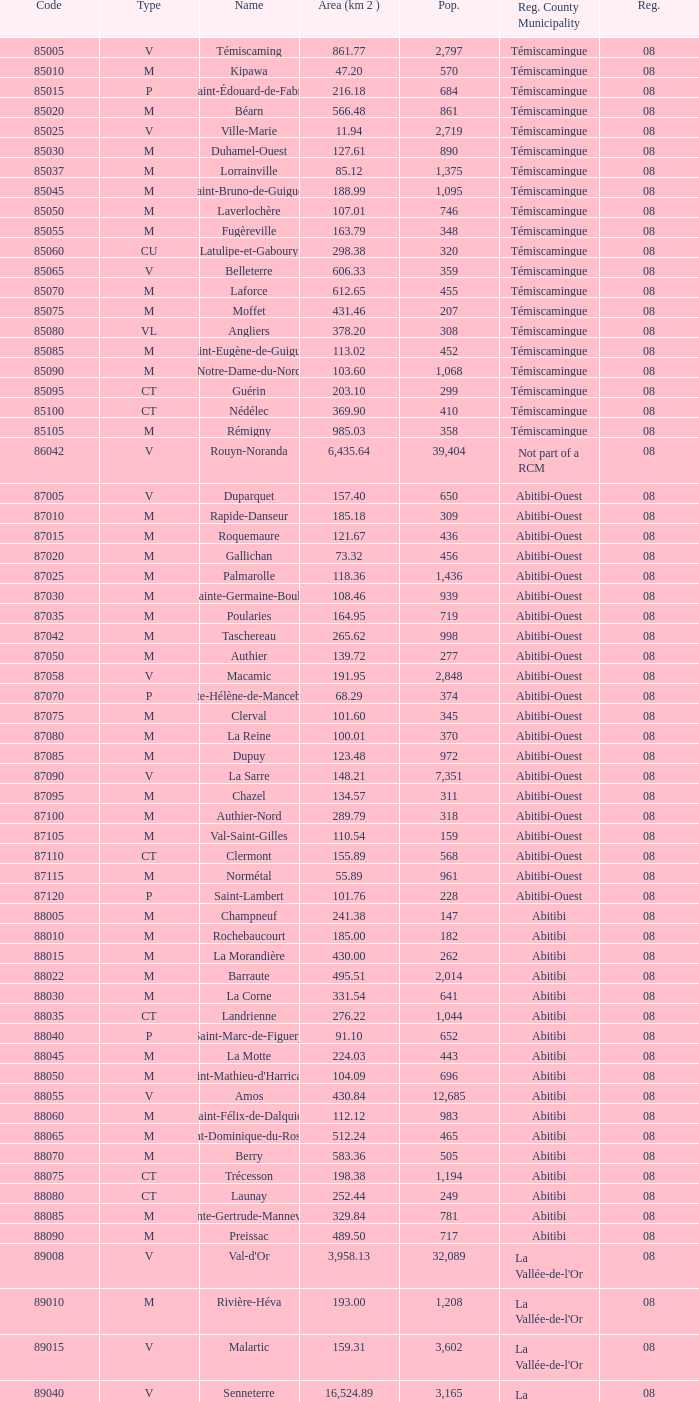What is Dupuy lowest area in km2? 123.48. 